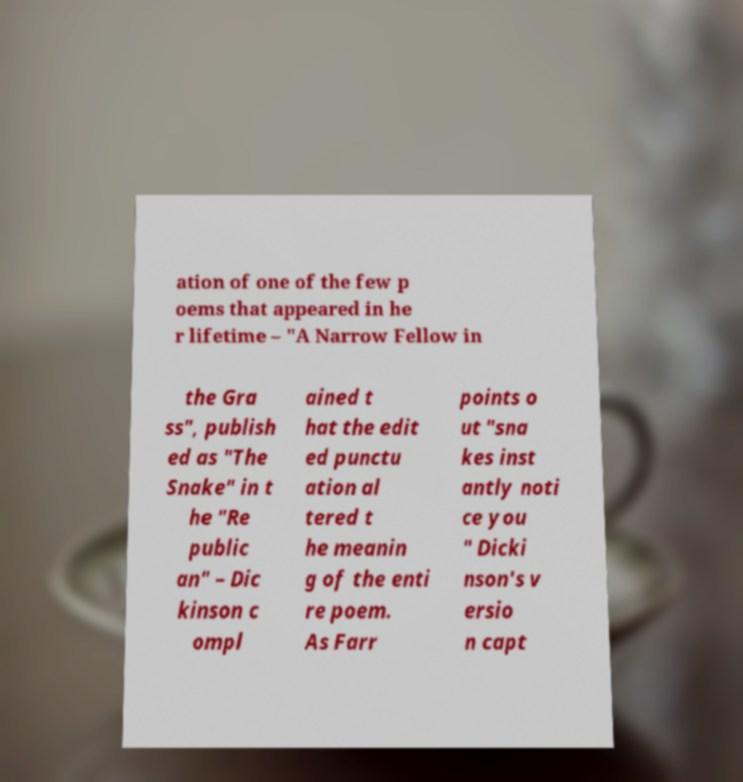Can you read and provide the text displayed in the image?This photo seems to have some interesting text. Can you extract and type it out for me? ation of one of the few p oems that appeared in he r lifetime – "A Narrow Fellow in the Gra ss", publish ed as "The Snake" in t he "Re public an" – Dic kinson c ompl ained t hat the edit ed punctu ation al tered t he meanin g of the enti re poem. As Farr points o ut "sna kes inst antly noti ce you " Dicki nson's v ersio n capt 